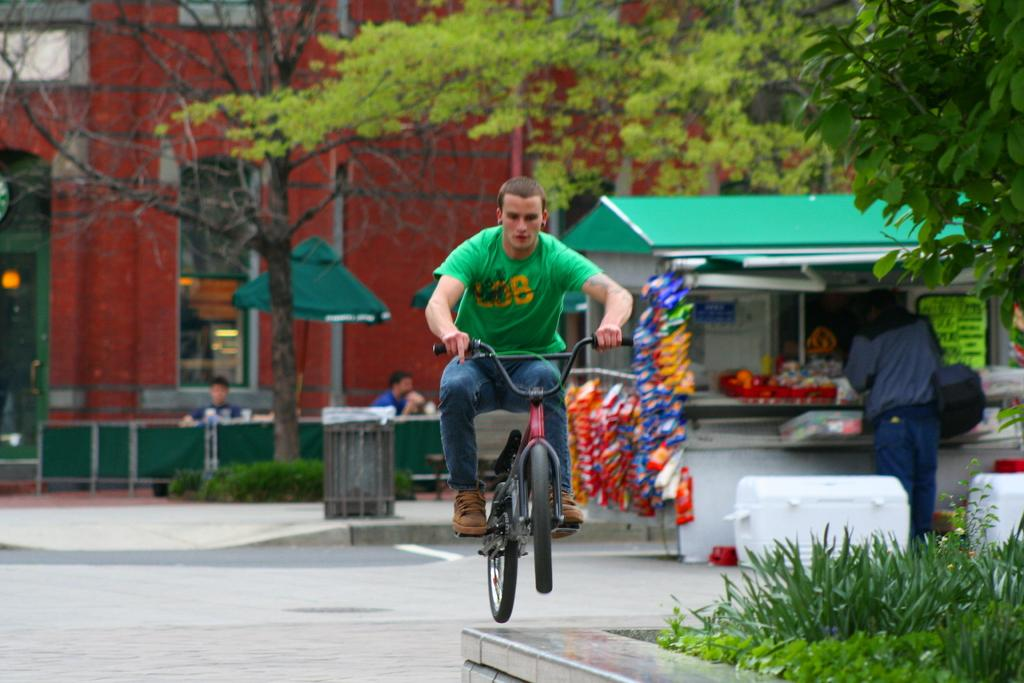What is the person in the image doing? The person is riding a bicycle. What can be seen in the background behind the person? There is a building, big trees, and a store behind the person. How many toes can be seen on the person's foot in the image? There is no visible foot or toes of the person in the image, as they are riding a bicycle. 